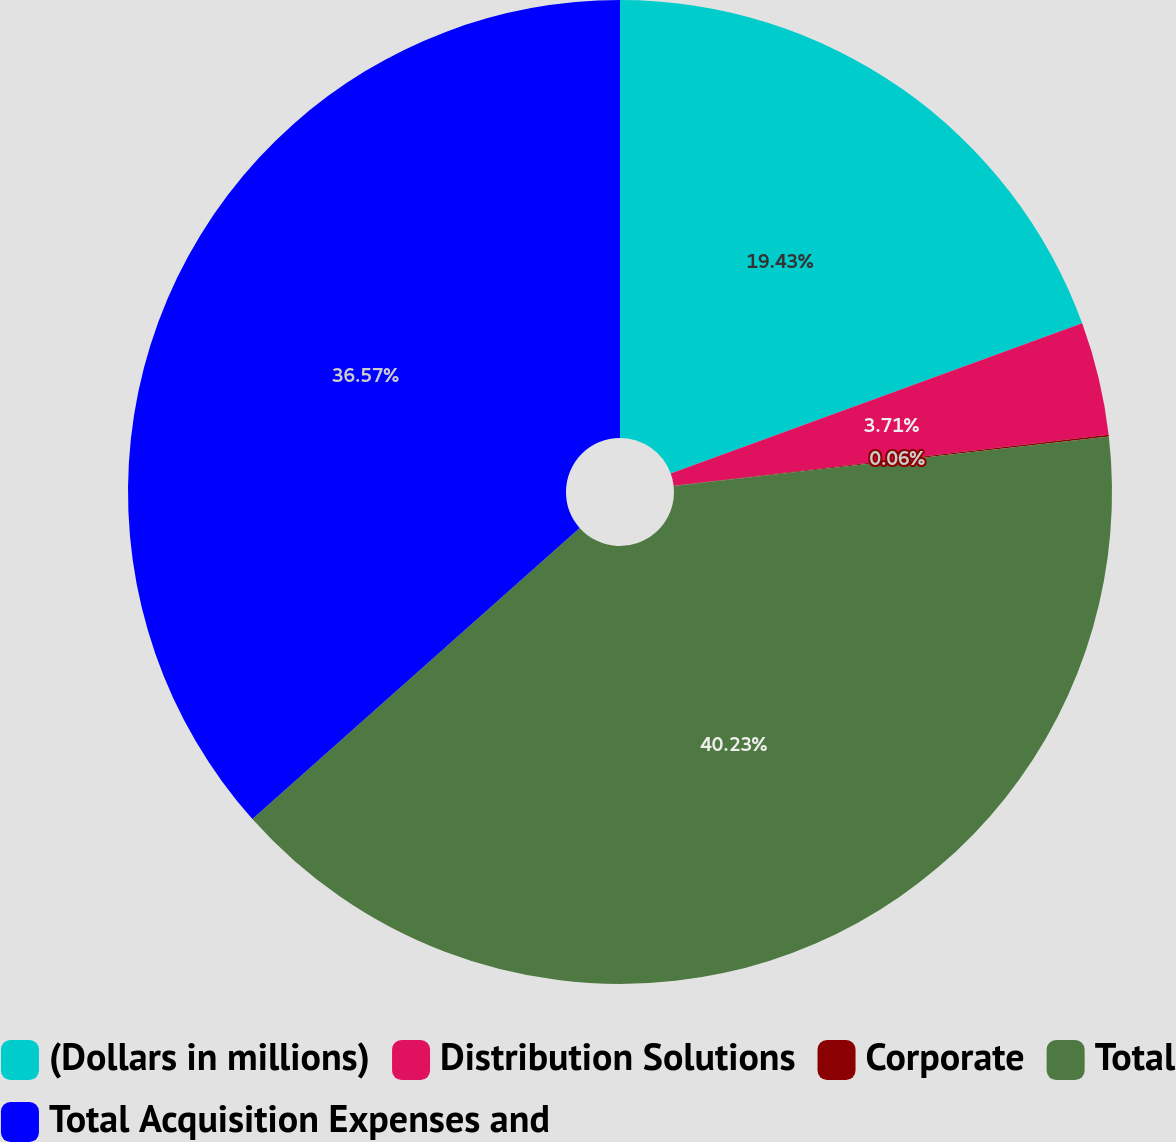Convert chart. <chart><loc_0><loc_0><loc_500><loc_500><pie_chart><fcel>(Dollars in millions)<fcel>Distribution Solutions<fcel>Corporate<fcel>Total<fcel>Total Acquisition Expenses and<nl><fcel>19.43%<fcel>3.71%<fcel>0.06%<fcel>40.23%<fcel>36.57%<nl></chart> 